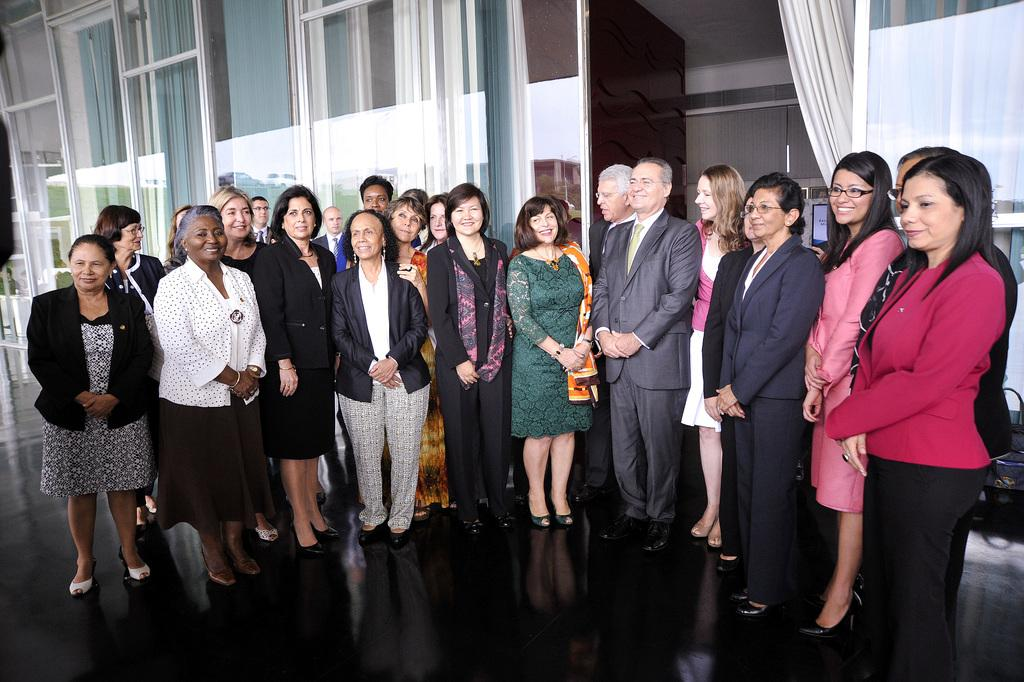What are the people in the image doing? There is a group of people standing and smiling in the image. What can be seen hanging on a hanger in the image? There are curtains hanging on a hanger in the image. What type of doors are visible in the image? There are glass doors visible in the image. What is the surface that the people are standing on in the image? There is a floor in the image. Can you tell me how many potatoes are on the floor in the image? There are no potatoes present in the image; it only features a group of people, curtains hanging on a hanger, glass doors, and a floor. 